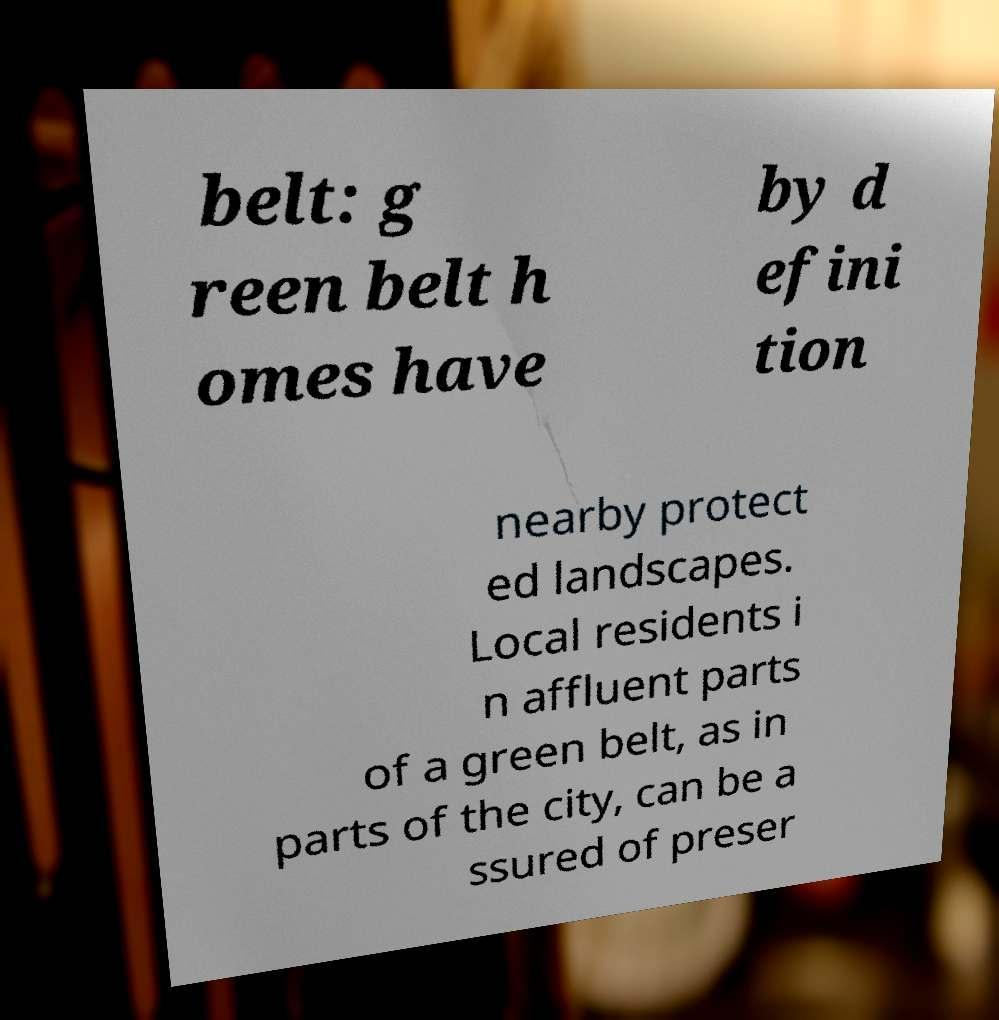Can you read and provide the text displayed in the image?This photo seems to have some interesting text. Can you extract and type it out for me? belt: g reen belt h omes have by d efini tion nearby protect ed landscapes. Local residents i n affluent parts of a green belt, as in parts of the city, can be a ssured of preser 